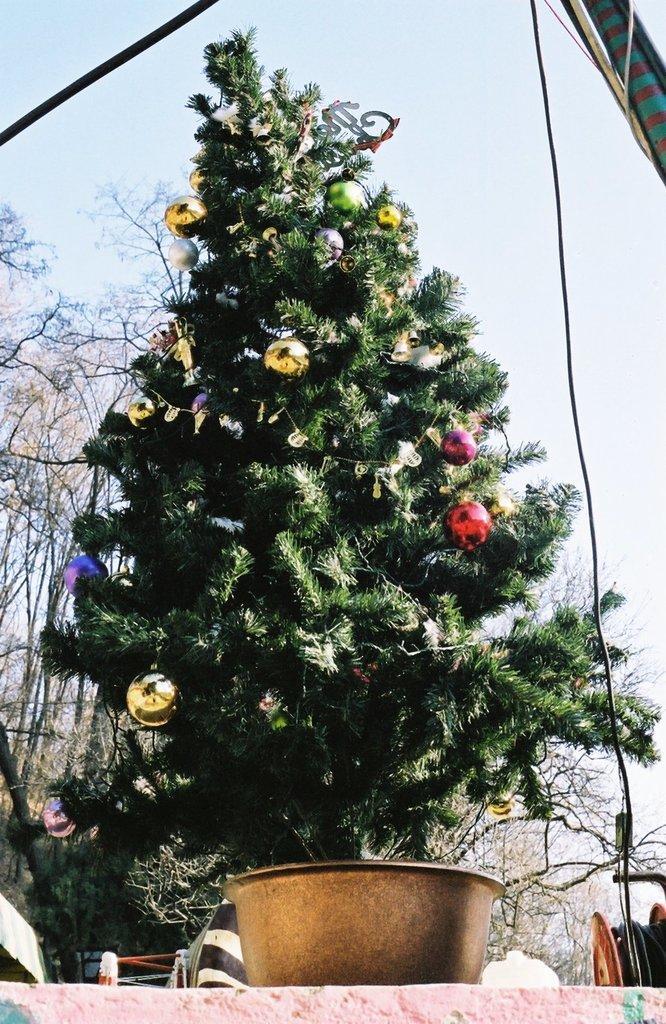In one or two sentences, can you explain what this image depicts? In this image I can see there is the Christmas tree, decorated with balls, at the back side there are trees. At the top it is the sky. 